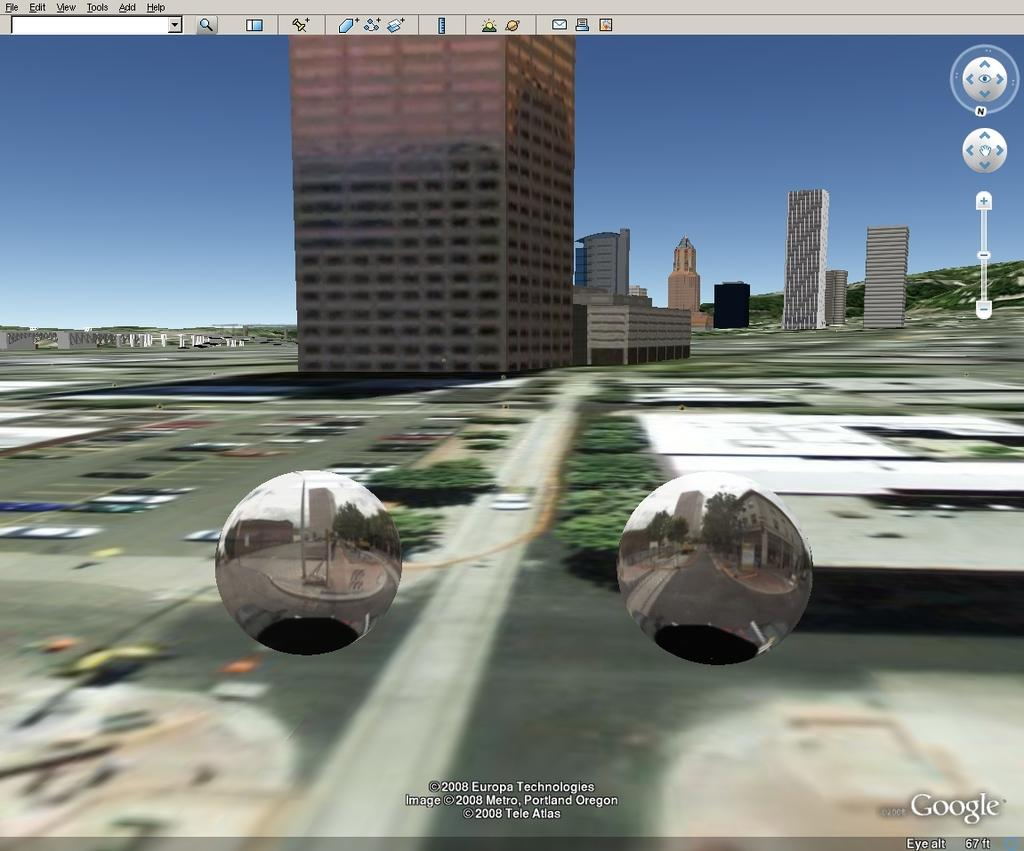What type of image is being described? The image is graphical in nature. What structures can be seen in the image? There are buildings in the image. What type of vegetation is present in the image? There are trees in the image. What type of current can be seen flowing through the trees in the image? There is no current visible in the image; it is a graphical representation of buildings and trees. 